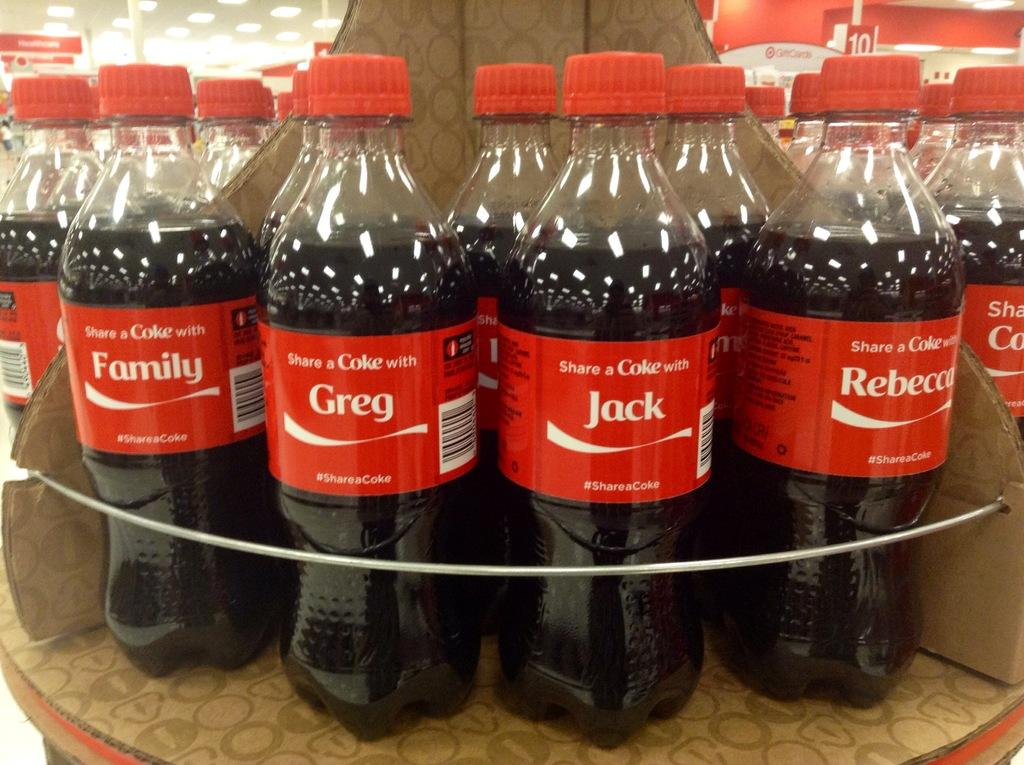<image>
Present a compact description of the photo's key features. Many bottles of cokes with names like Greg, Jack, and Rebecca on them. 